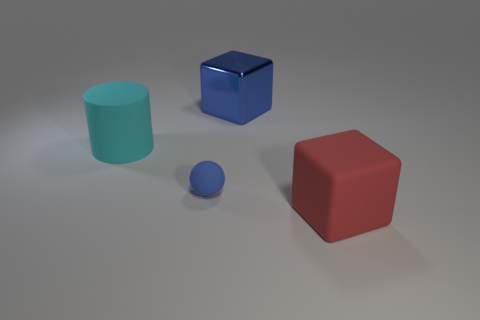Add 3 matte spheres. How many objects exist? 7 Subtract all red blocks. How many blocks are left? 1 Subtract all cylinders. How many objects are left? 3 Subtract 1 blocks. How many blocks are left? 1 Subtract all large cyan objects. Subtract all red rubber objects. How many objects are left? 2 Add 4 big rubber blocks. How many big rubber blocks are left? 5 Add 1 small brown metal spheres. How many small brown metal spheres exist? 1 Subtract 0 red spheres. How many objects are left? 4 Subtract all brown spheres. Subtract all gray cubes. How many spheres are left? 1 Subtract all blue cylinders. How many purple blocks are left? 0 